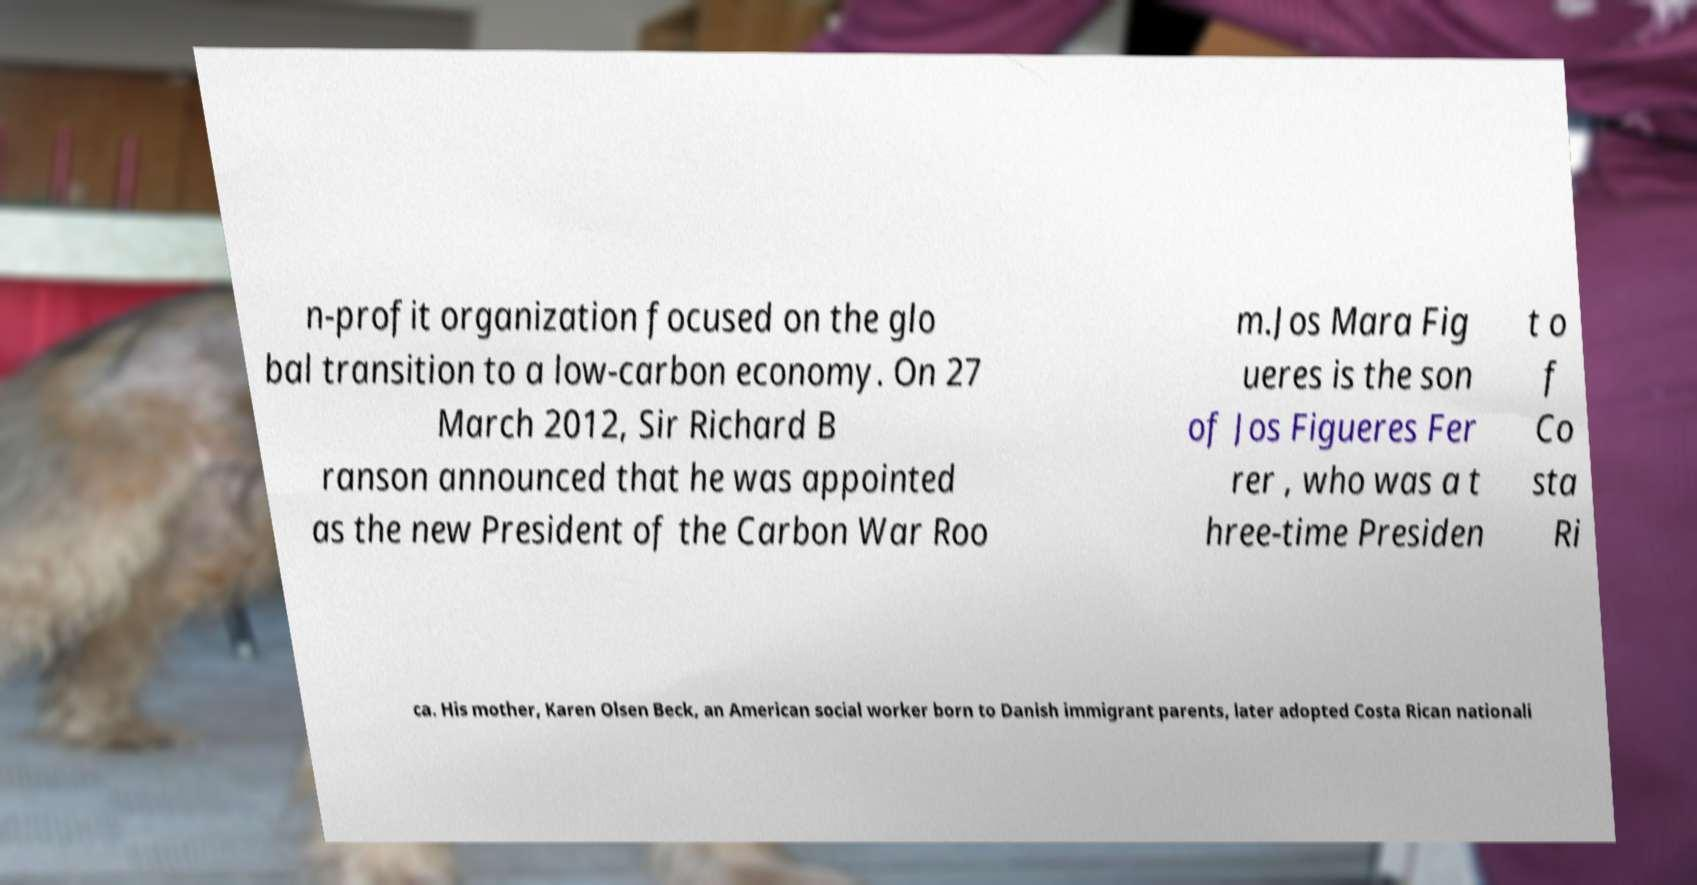There's text embedded in this image that I need extracted. Can you transcribe it verbatim? n-profit organization focused on the glo bal transition to a low-carbon economy. On 27 March 2012, Sir Richard B ranson announced that he was appointed as the new President of the Carbon War Roo m.Jos Mara Fig ueres is the son of Jos Figueres Fer rer , who was a t hree-time Presiden t o f Co sta Ri ca. His mother, Karen Olsen Beck, an American social worker born to Danish immigrant parents, later adopted Costa Rican nationali 